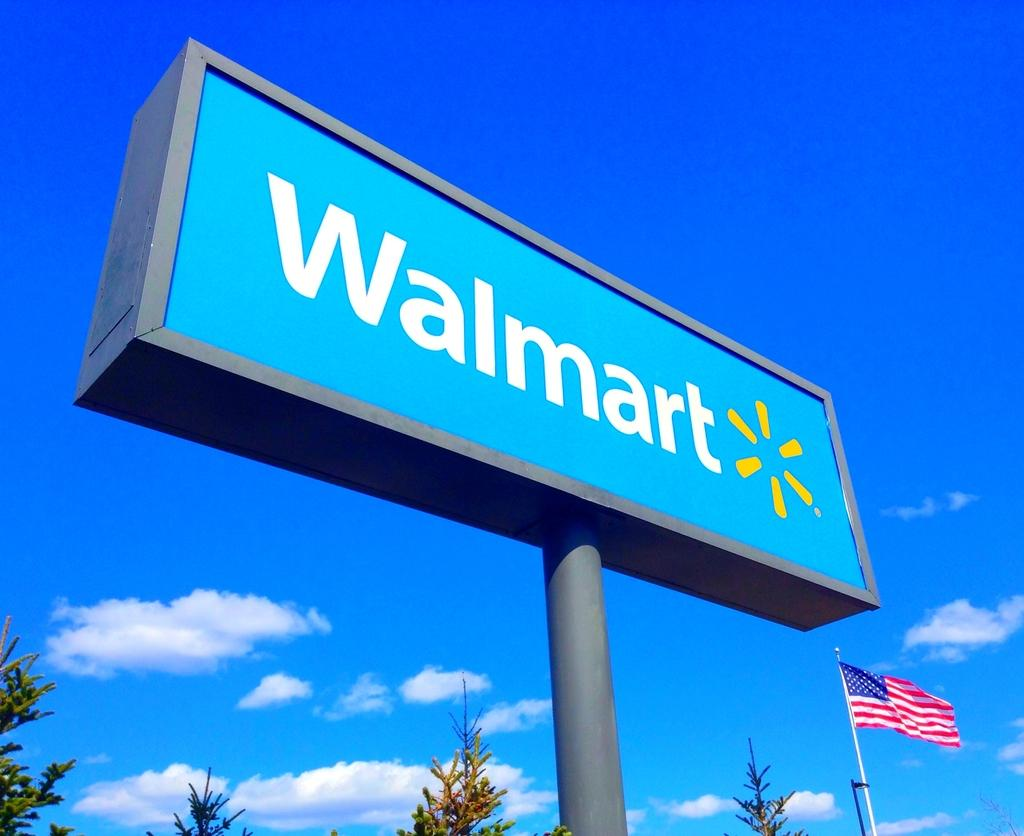What is the main object in the image? There is a banner board in the image. What type of vegetation can be seen at the bottom of the image? Greenery is visible at the bottom of the image. What structures are present in the image? There are poles in the image. What is attached to the poles? There is a flag in the image. What can be seen in the background of the image? The sky is visible in the background of the image. What is the condition of the sky in the image? Clouds are present in the sky. What type of floor can be seen in the image? There is no floor visible in the image; it is an outdoor scene with a banner board, greenery, poles, flag, and sky. 